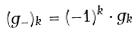<formula> <loc_0><loc_0><loc_500><loc_500>( g _ { - } ) _ { k } = ( - 1 ) ^ { k } \cdot g _ { k }</formula> 